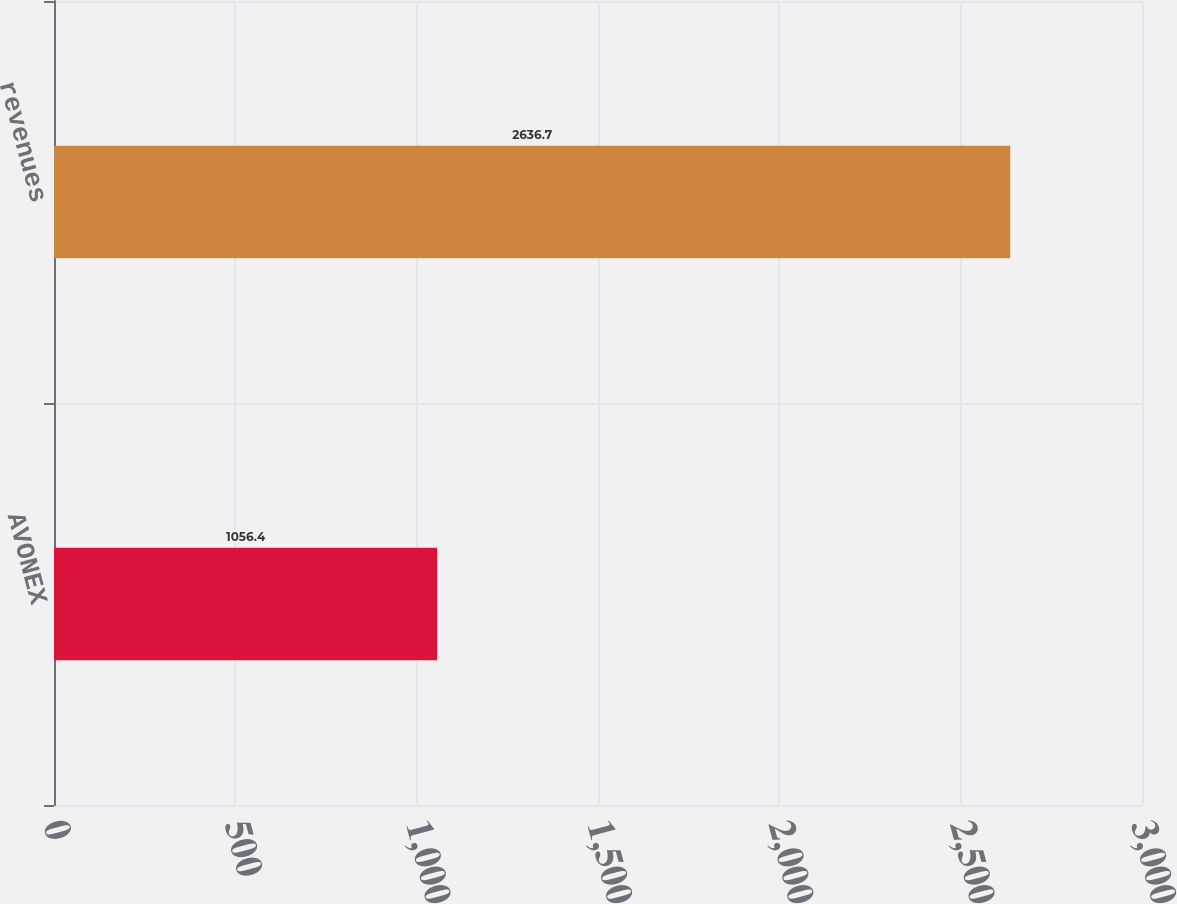Convert chart to OTSL. <chart><loc_0><loc_0><loc_500><loc_500><bar_chart><fcel>AVONEX<fcel>revenues<nl><fcel>1056.4<fcel>2636.7<nl></chart> 